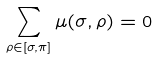Convert formula to latex. <formula><loc_0><loc_0><loc_500><loc_500>\sum _ { \rho \in [ \sigma , \pi ] } { \mu ( \sigma , \rho ) } = 0</formula> 